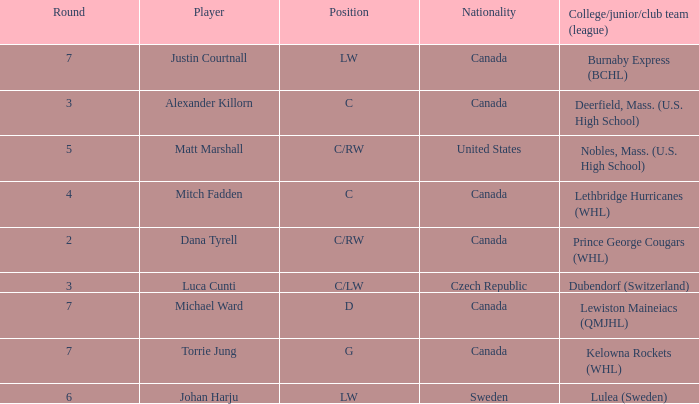What College/junior/club team (league) did mitch fadden play for? Lethbridge Hurricanes (WHL). 